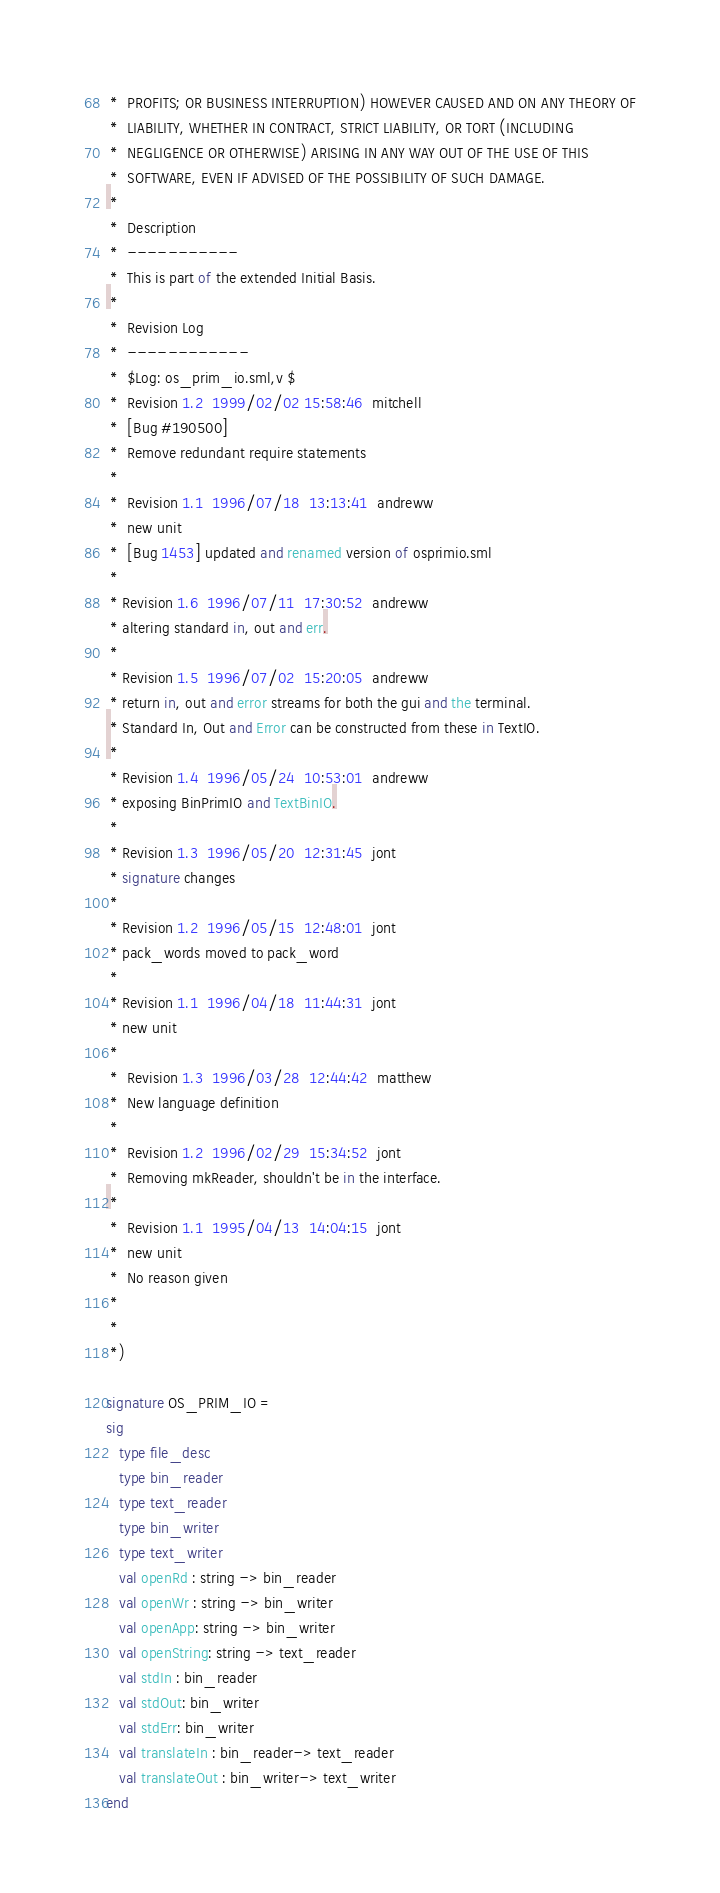<code> <loc_0><loc_0><loc_500><loc_500><_SML_> *  PROFITS; OR BUSINESS INTERRUPTION) HOWEVER CAUSED AND ON ANY THEORY OF
 *  LIABILITY, WHETHER IN CONTRACT, STRICT LIABILITY, OR TORT (INCLUDING
 *  NEGLIGENCE OR OTHERWISE) ARISING IN ANY WAY OUT OF THE USE OF THIS
 *  SOFTWARE, EVEN IF ADVISED OF THE POSSIBILITY OF SUCH DAMAGE.
 *
 *  Description
 *  -----------
 *  This is part of the extended Initial Basis.
 *
 *  Revision Log
 *  ------------
 *  $Log: os_prim_io.sml,v $
 *  Revision 1.2  1999/02/02 15:58:46  mitchell
 *  [Bug #190500]
 *  Remove redundant require statements
 *
 *  Revision 1.1  1996/07/18  13:13:41  andreww
 *  new unit
 *  [Bug 1453] updated and renamed version of osprimio.sml
 *
 * Revision 1.6  1996/07/11  17:30:52  andreww
 * altering standard in, out and err.
 *
 * Revision 1.5  1996/07/02  15:20:05  andreww
 * return in, out and error streams for both the gui and the terminal.
 * Standard In, Out and Error can be constructed from these in TextIO.
 *
 * Revision 1.4  1996/05/24  10:53:01  andreww
 * exposing BinPrimIO and TextBinIO.
 *
 * Revision 1.3  1996/05/20  12:31:45  jont
 * signature changes
 *
 * Revision 1.2  1996/05/15  12:48:01  jont
 * pack_words moved to pack_word
 *
 * Revision 1.1  1996/04/18  11:44:31  jont
 * new unit
 *
 *  Revision 1.3  1996/03/28  12:44:42  matthew
 *  New language definition
 *
 *  Revision 1.2  1996/02/29  15:34:52  jont
 *  Removing mkReader, shouldn't be in the interface.
 *
 *  Revision 1.1  1995/04/13  14:04:15  jont
 *  new unit
 *  No reason given
 *
 *
 *)

signature OS_PRIM_IO =
sig
   type file_desc
   type bin_reader
   type text_reader
   type bin_writer
   type text_writer
   val openRd : string -> bin_reader
   val openWr : string -> bin_writer
   val openApp: string -> bin_writer
   val openString: string -> text_reader
   val stdIn : bin_reader
   val stdOut: bin_writer
   val stdErr: bin_writer
   val translateIn : bin_reader-> text_reader
   val translateOut : bin_writer-> text_writer
end

</code> 